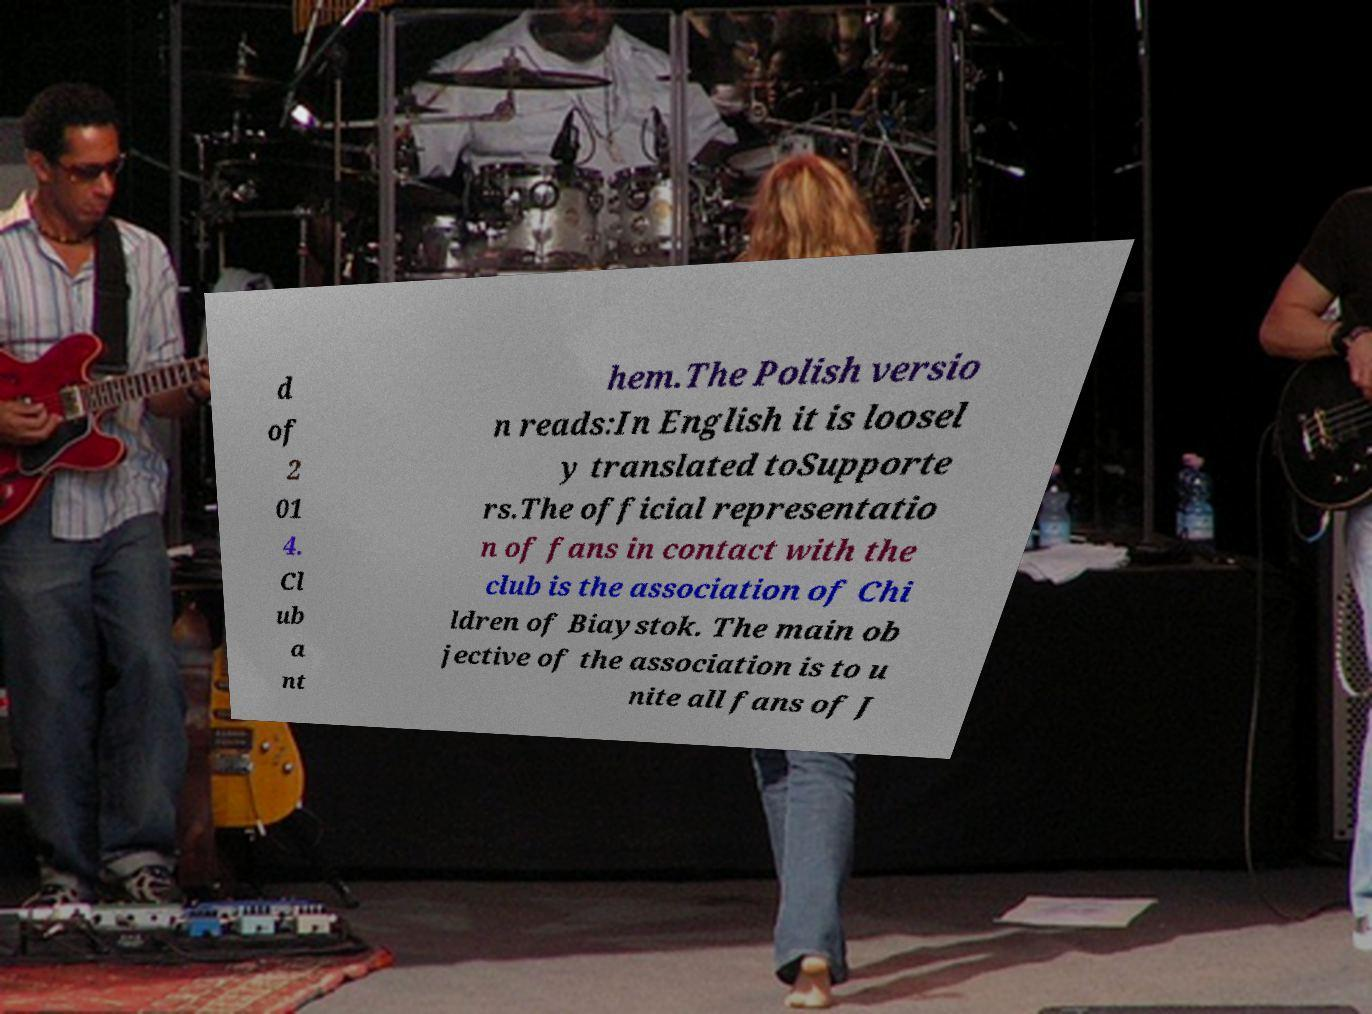Please identify and transcribe the text found in this image. d of 2 01 4. Cl ub a nt hem.The Polish versio n reads:In English it is loosel y translated toSupporte rs.The official representatio n of fans in contact with the club is the association of Chi ldren of Biaystok. The main ob jective of the association is to u nite all fans of J 